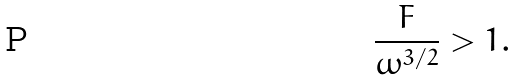Convert formula to latex. <formula><loc_0><loc_0><loc_500><loc_500>\frac { F } { \omega ^ { 3 / 2 } } > 1 .</formula> 